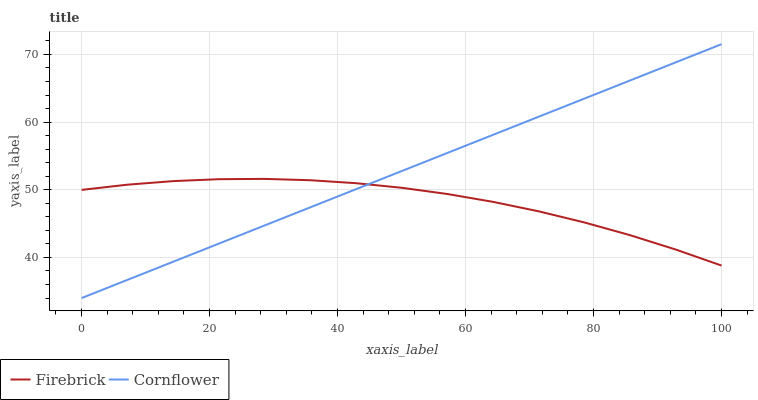Does Firebrick have the minimum area under the curve?
Answer yes or no. Yes. Does Cornflower have the maximum area under the curve?
Answer yes or no. Yes. Does Firebrick have the maximum area under the curve?
Answer yes or no. No. Is Cornflower the smoothest?
Answer yes or no. Yes. Is Firebrick the roughest?
Answer yes or no. Yes. Is Firebrick the smoothest?
Answer yes or no. No. Does Cornflower have the lowest value?
Answer yes or no. Yes. Does Firebrick have the lowest value?
Answer yes or no. No. Does Cornflower have the highest value?
Answer yes or no. Yes. Does Firebrick have the highest value?
Answer yes or no. No. Does Firebrick intersect Cornflower?
Answer yes or no. Yes. Is Firebrick less than Cornflower?
Answer yes or no. No. Is Firebrick greater than Cornflower?
Answer yes or no. No. 